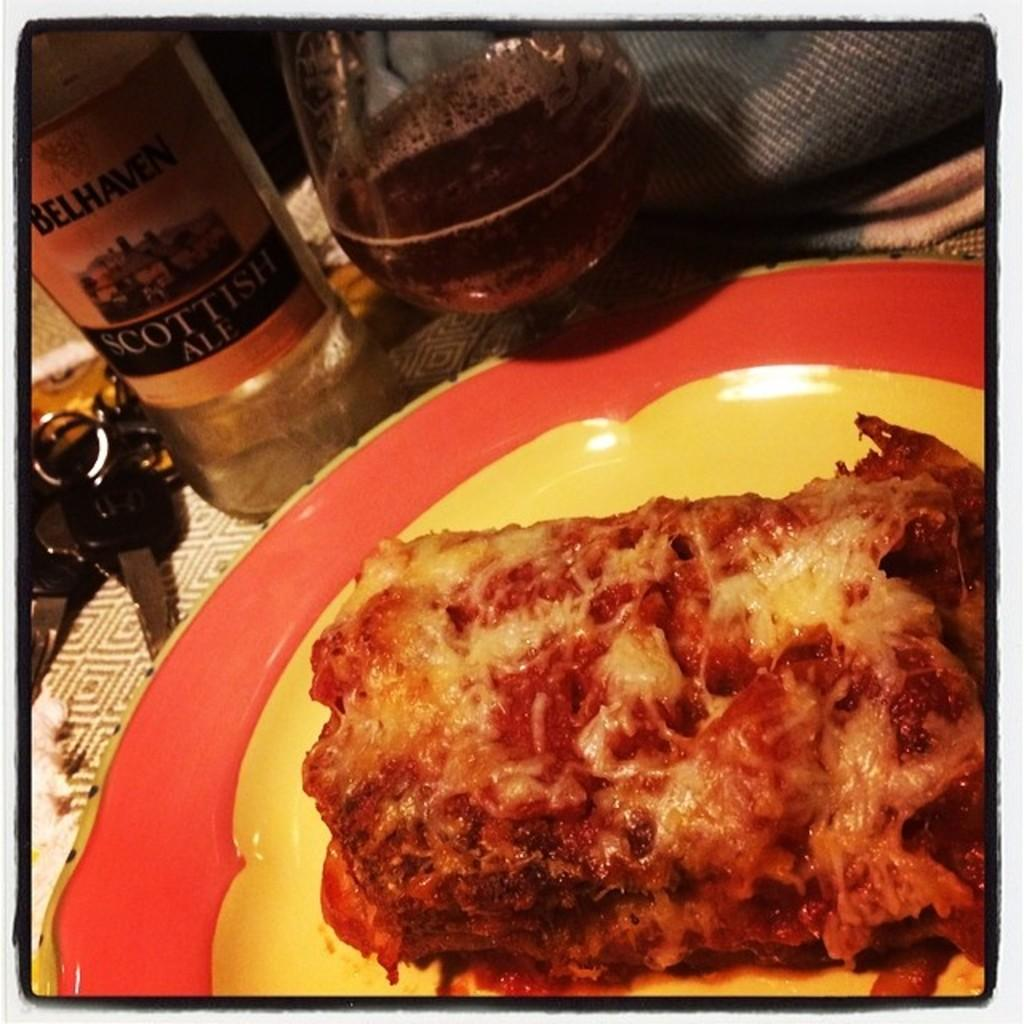Provide a one-sentence caption for the provided image. a bottle of Scottish Ale is behind a plate of lasagne. 